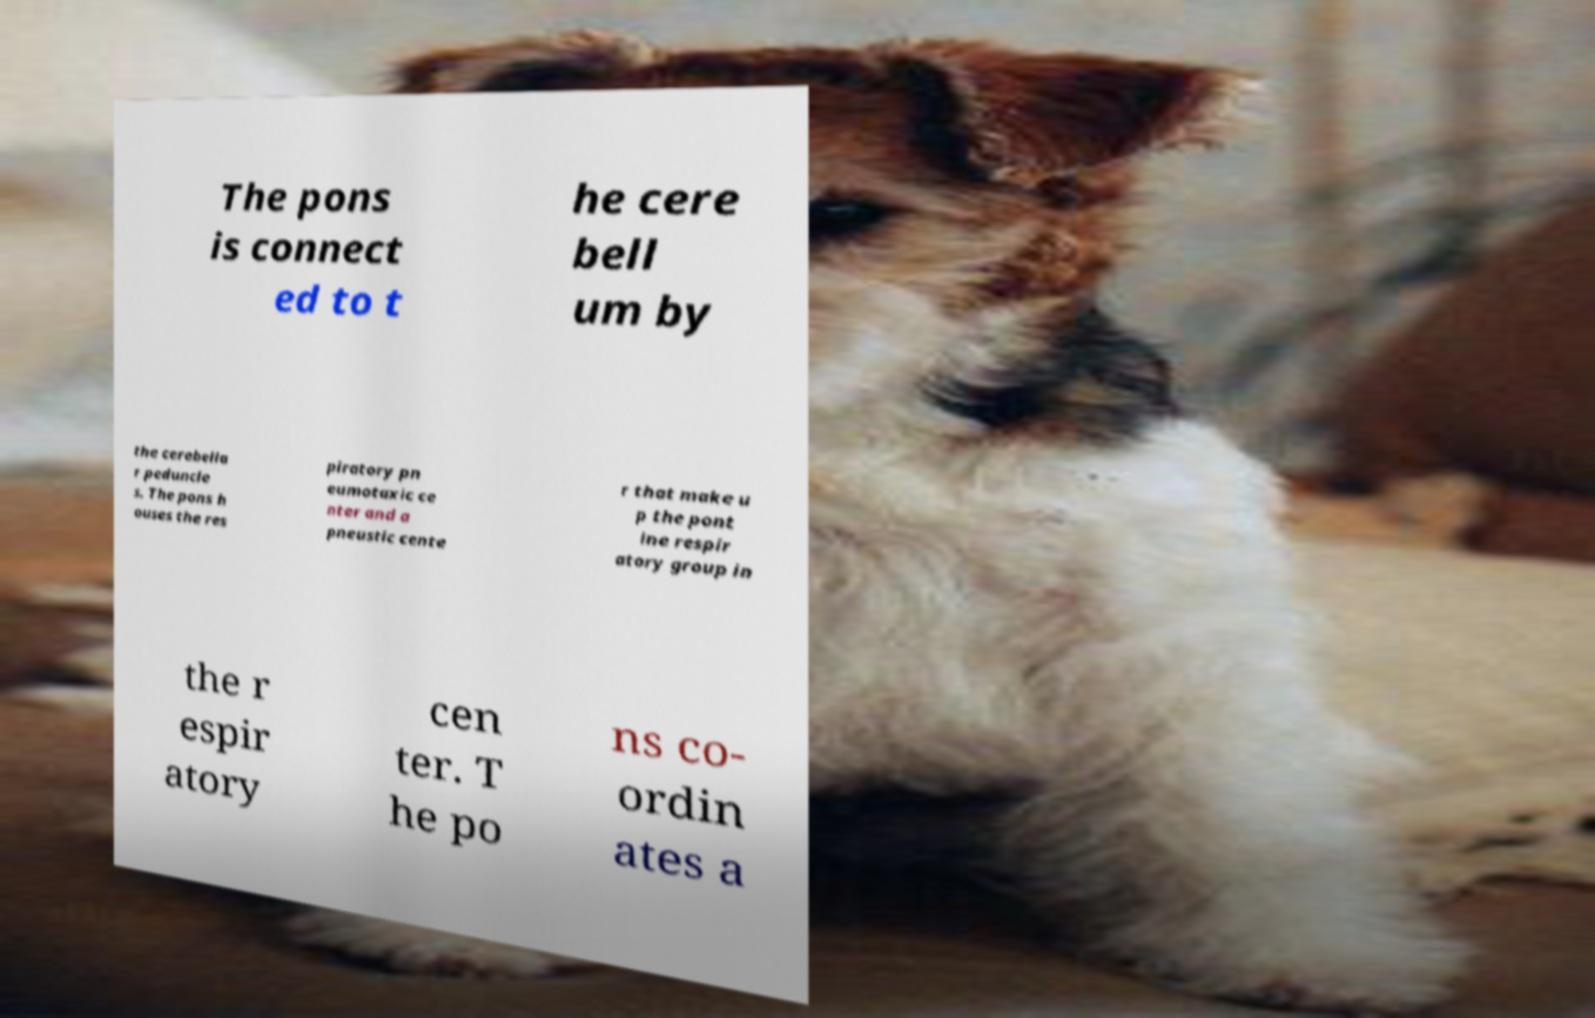What messages or text are displayed in this image? I need them in a readable, typed format. The pons is connect ed to t he cere bell um by the cerebella r peduncle s. The pons h ouses the res piratory pn eumotaxic ce nter and a pneustic cente r that make u p the pont ine respir atory group in the r espir atory cen ter. T he po ns co- ordin ates a 